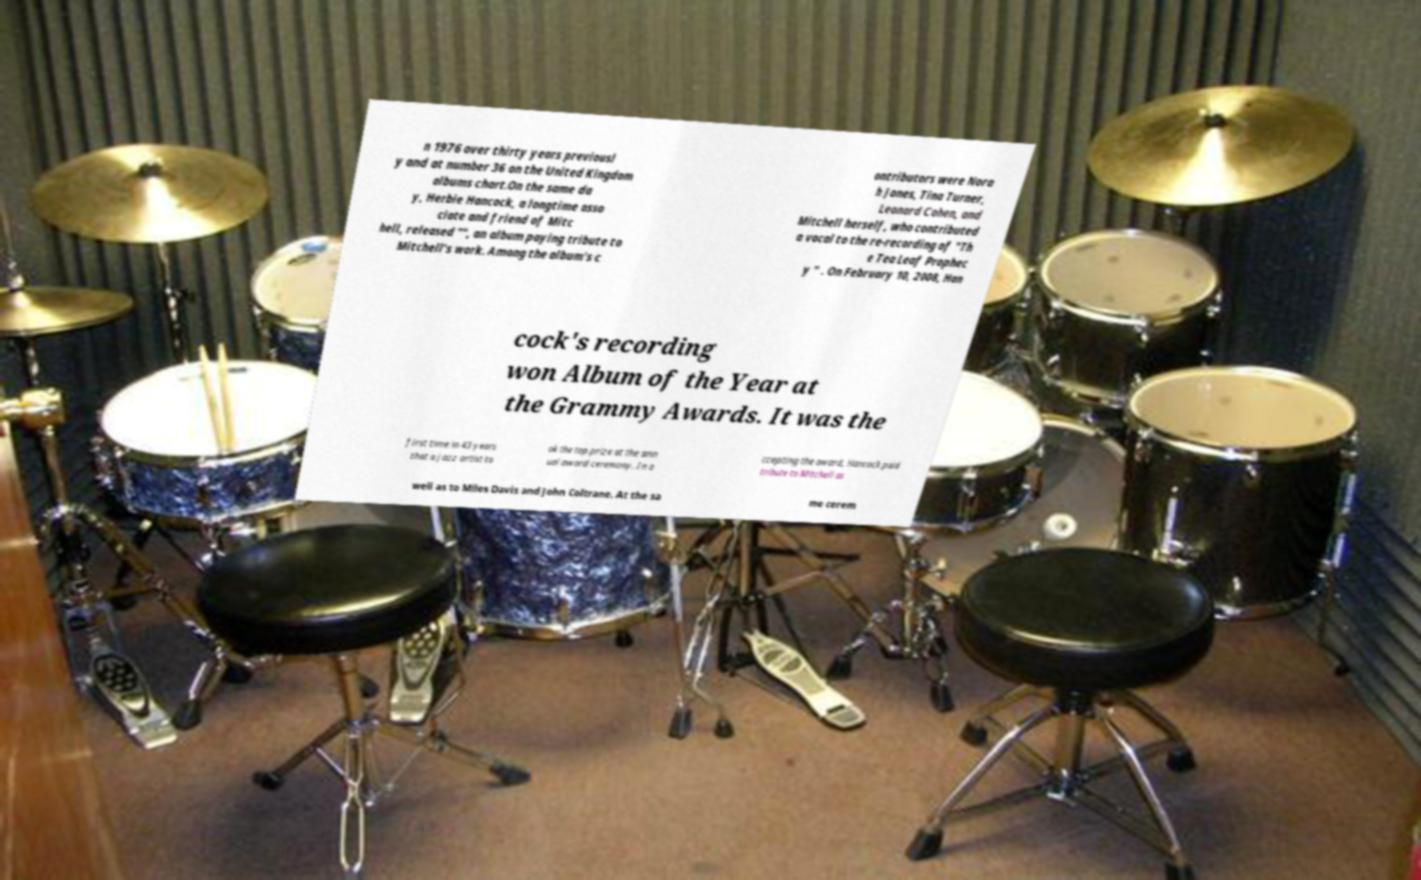For documentation purposes, I need the text within this image transcribed. Could you provide that? n 1976 over thirty years previousl y and at number 36 on the United Kingdom albums chart.On the same da y, Herbie Hancock, a longtime asso ciate and friend of Mitc hell, released "", an album paying tribute to Mitchell's work. Among the album's c ontributors were Nora h Jones, Tina Turner, Leonard Cohen, and Mitchell herself, who contributed a vocal to the re-recording of "Th e Tea Leaf Prophec y " . On February 10, 2008, Han cock's recording won Album of the Year at the Grammy Awards. It was the first time in 43 years that a jazz artist to ok the top prize at the ann ual award ceremony. In a ccepting the award, Hancock paid tribute to Mitchell as well as to Miles Davis and John Coltrane. At the sa me cerem 